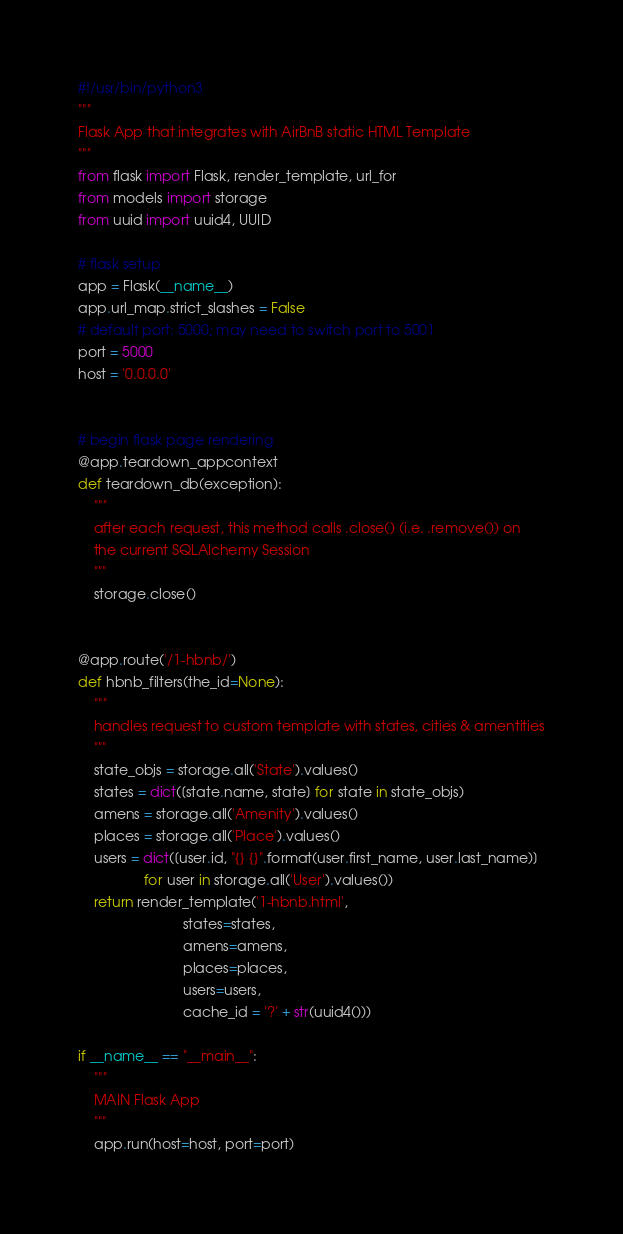Convert code to text. <code><loc_0><loc_0><loc_500><loc_500><_Python_>#!/usr/bin/python3
"""
Flask App that integrates with AirBnB static HTML Template
"""
from flask import Flask, render_template, url_for
from models import storage
from uuid import uuid4, UUID

# flask setup
app = Flask(__name__)
app.url_map.strict_slashes = False
# default port: 5000; may need to switch port to 5001
port = 5000
host = '0.0.0.0'


# begin flask page rendering
@app.teardown_appcontext
def teardown_db(exception):
    """
    after each request, this method calls .close() (i.e. .remove()) on
    the current SQLAlchemy Session
    """
    storage.close()


@app.route('/1-hbnb/')
def hbnb_filters(the_id=None):
    """
    handles request to custom template with states, cities & amentities
    """
    state_objs = storage.all('State').values()
    states = dict([state.name, state] for state in state_objs)
    amens = storage.all('Amenity').values()
    places = storage.all('Place').values()
    users = dict([user.id, "{} {}".format(user.first_name, user.last_name)]
                 for user in storage.all('User').values())
    return render_template('1-hbnb.html',
                           states=states,
                           amens=amens,
                           places=places,
                           users=users,
                           cache_id = '?' + str(uuid4()))
                           
if __name__ == "__main__":
    """
    MAIN Flask App
    """
    app.run(host=host, port=port)
</code> 